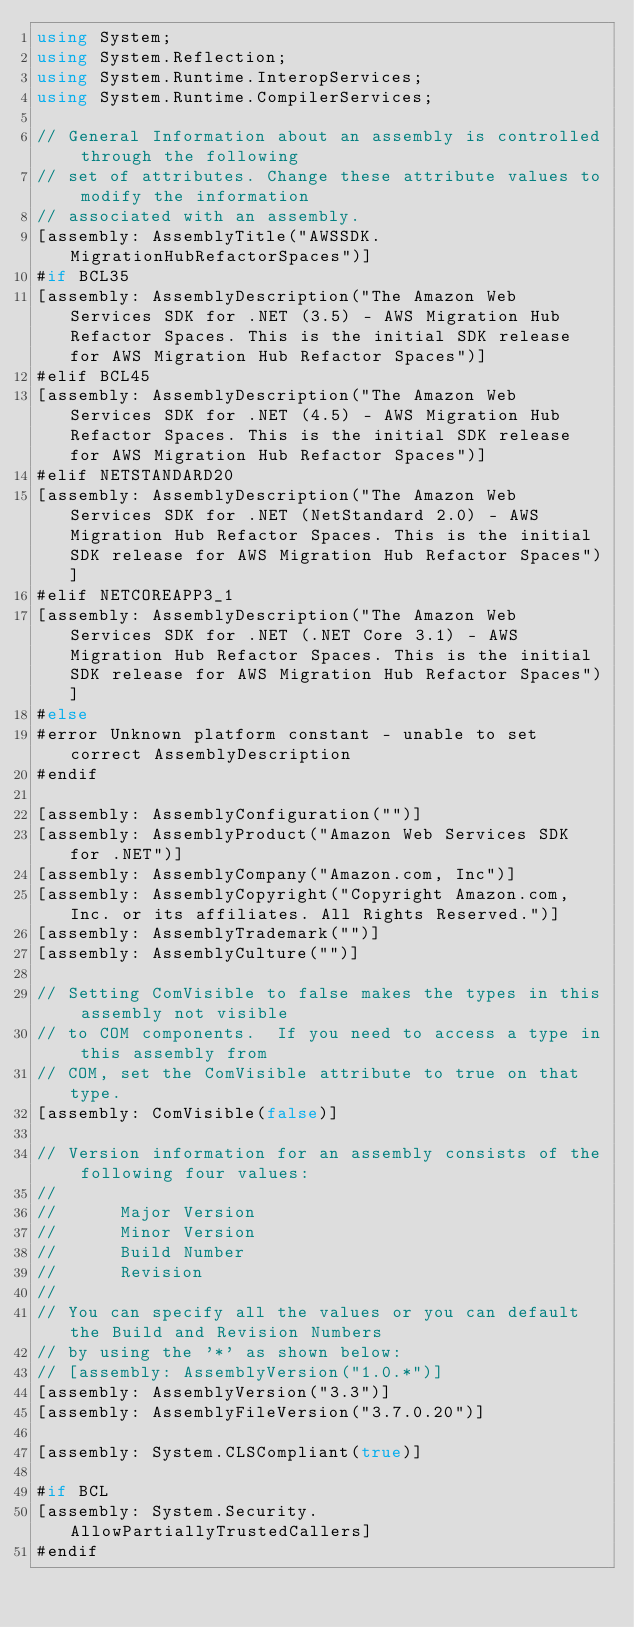<code> <loc_0><loc_0><loc_500><loc_500><_C#_>using System;
using System.Reflection;
using System.Runtime.InteropServices;
using System.Runtime.CompilerServices;

// General Information about an assembly is controlled through the following 
// set of attributes. Change these attribute values to modify the information
// associated with an assembly.
[assembly: AssemblyTitle("AWSSDK.MigrationHubRefactorSpaces")]
#if BCL35
[assembly: AssemblyDescription("The Amazon Web Services SDK for .NET (3.5) - AWS Migration Hub Refactor Spaces. This is the initial SDK release for AWS Migration Hub Refactor Spaces")]
#elif BCL45
[assembly: AssemblyDescription("The Amazon Web Services SDK for .NET (4.5) - AWS Migration Hub Refactor Spaces. This is the initial SDK release for AWS Migration Hub Refactor Spaces")]
#elif NETSTANDARD20
[assembly: AssemblyDescription("The Amazon Web Services SDK for .NET (NetStandard 2.0) - AWS Migration Hub Refactor Spaces. This is the initial SDK release for AWS Migration Hub Refactor Spaces")]
#elif NETCOREAPP3_1
[assembly: AssemblyDescription("The Amazon Web Services SDK for .NET (.NET Core 3.1) - AWS Migration Hub Refactor Spaces. This is the initial SDK release for AWS Migration Hub Refactor Spaces")]
#else
#error Unknown platform constant - unable to set correct AssemblyDescription
#endif

[assembly: AssemblyConfiguration("")]
[assembly: AssemblyProduct("Amazon Web Services SDK for .NET")]
[assembly: AssemblyCompany("Amazon.com, Inc")]
[assembly: AssemblyCopyright("Copyright Amazon.com, Inc. or its affiliates. All Rights Reserved.")]
[assembly: AssemblyTrademark("")]
[assembly: AssemblyCulture("")]

// Setting ComVisible to false makes the types in this assembly not visible 
// to COM components.  If you need to access a type in this assembly from 
// COM, set the ComVisible attribute to true on that type.
[assembly: ComVisible(false)]

// Version information for an assembly consists of the following four values:
//
//      Major Version
//      Minor Version 
//      Build Number
//      Revision
//
// You can specify all the values or you can default the Build and Revision Numbers 
// by using the '*' as shown below:
// [assembly: AssemblyVersion("1.0.*")]
[assembly: AssemblyVersion("3.3")]
[assembly: AssemblyFileVersion("3.7.0.20")]

[assembly: System.CLSCompliant(true)]

#if BCL
[assembly: System.Security.AllowPartiallyTrustedCallers]
#endif</code> 